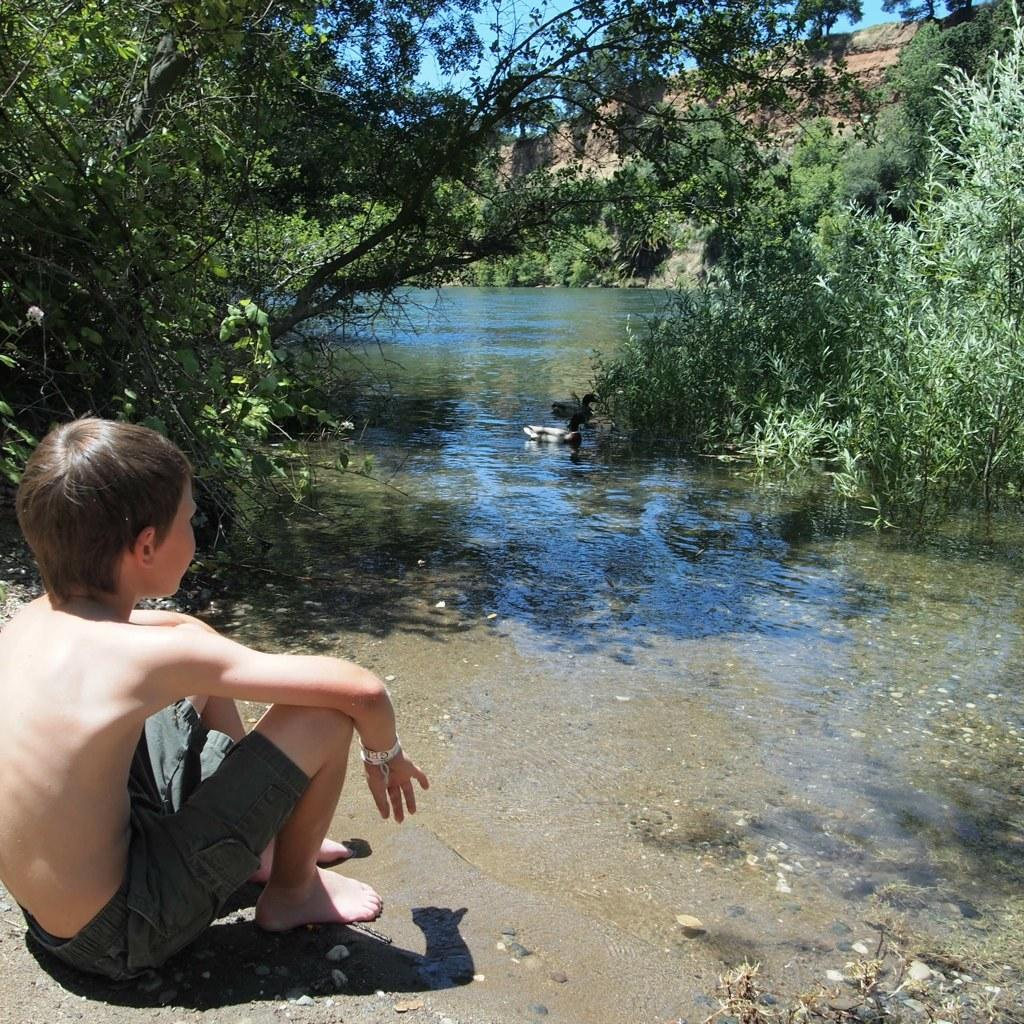Who is present in the image? There is a boy in the image. Where is the boy located? The boy is sitting by a lake. What can be seen on either side of the lake? There are trees on either side of the lake. What type of silk is the boy wearing in the image? There is no mention of silk or any clothing in the image; the boy is simply sitting by the lake. 